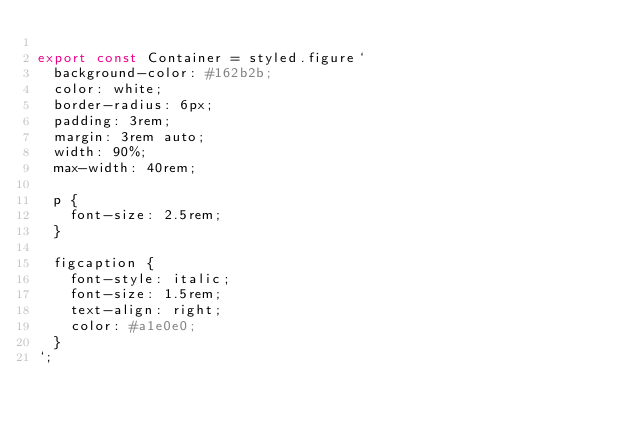<code> <loc_0><loc_0><loc_500><loc_500><_JavaScript_>
export const Container = styled.figure`
  background-color: #162b2b;
  color: white;
  border-radius: 6px;
  padding: 3rem;
  margin: 3rem auto;
  width: 90%;
  max-width: 40rem;

  p {
    font-size: 2.5rem;
  }

  figcaption {
    font-style: italic;
    font-size: 1.5rem;
    text-align: right;
    color: #a1e0e0;
  }
`;
</code> 